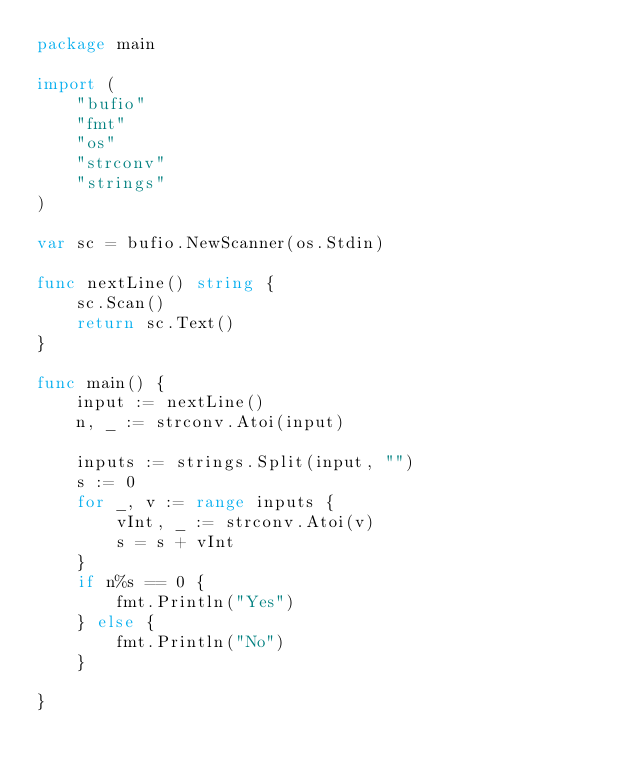Convert code to text. <code><loc_0><loc_0><loc_500><loc_500><_Go_>package main

import (
	"bufio"
	"fmt"
	"os"
	"strconv"
	"strings"
)

var sc = bufio.NewScanner(os.Stdin)

func nextLine() string {
	sc.Scan()
	return sc.Text()
}

func main() {
	input := nextLine()
	n, _ := strconv.Atoi(input)

	inputs := strings.Split(input, "")
	s := 0
	for _, v := range inputs {
		vInt, _ := strconv.Atoi(v)
		s = s + vInt
	}
	if n%s == 0 {
		fmt.Println("Yes")
	} else {
		fmt.Println("No")
	}

}
</code> 